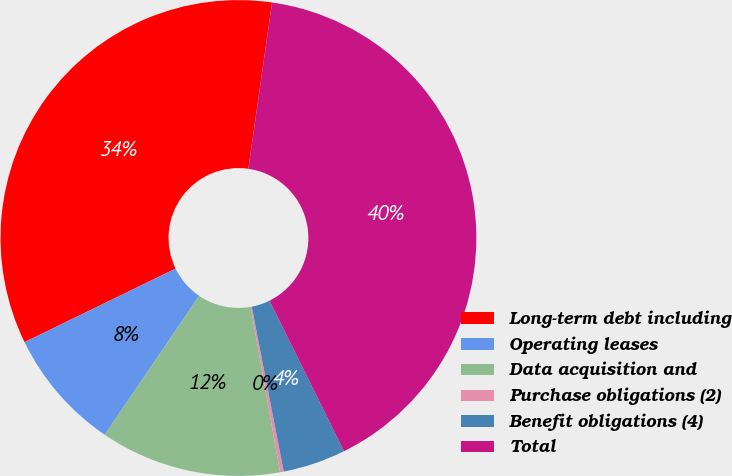<chart> <loc_0><loc_0><loc_500><loc_500><pie_chart><fcel>Long-term debt including<fcel>Operating leases<fcel>Data acquisition and<fcel>Purchase obligations (2)<fcel>Benefit obligations (4)<fcel>Total<nl><fcel>34.47%<fcel>8.29%<fcel>12.3%<fcel>0.25%<fcel>4.27%<fcel>40.43%<nl></chart> 